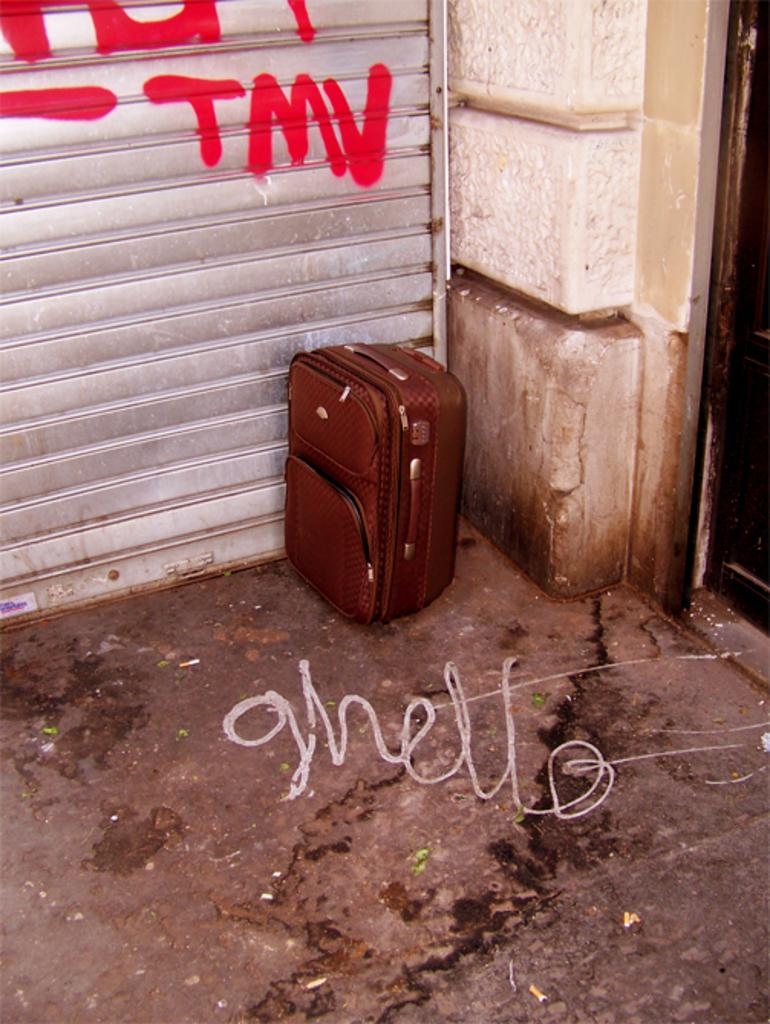What object can be seen in the image that is commonly used for carrying belongings? There is a luggage bag in the image. What is the color of the luggage bag? The luggage bag is brown in color. Where is the luggage bag located in the image? The luggage bag is placed at a corner. What is the luggage bag positioned beside in the image? The luggage bag is beside a shutter door. What type of toothpaste is being used to clean the luggage bag in the image? There is no toothpaste present in the image, and the luggage bag is not being cleaned. 